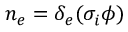Convert formula to latex. <formula><loc_0><loc_0><loc_500><loc_500>n _ { e } = \delta _ { e } ( \sigma _ { i } \phi )</formula> 